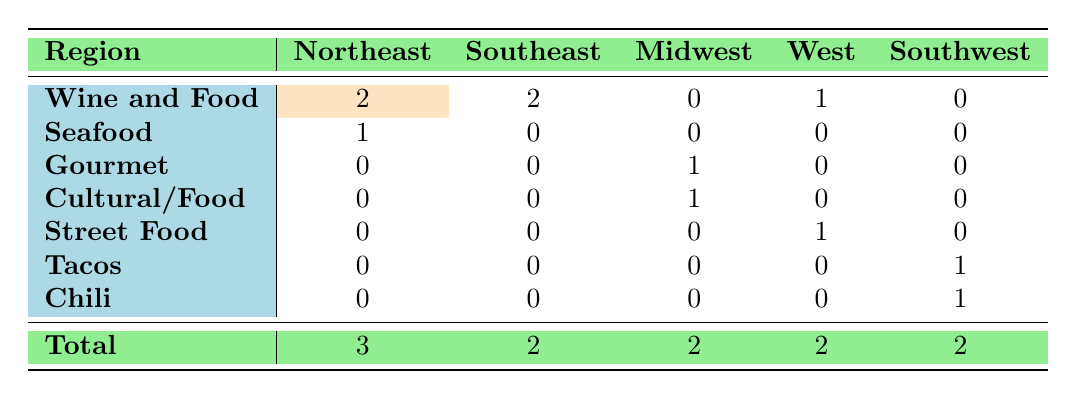What type of food festival has the highest attendance in the Northeast region? The table shows "New York City Wine & Food Festival" under the Northeast region with an attendance of 50,000, which is higher than any other festival in that region.
Answer: Wine and Food How many different types of food festivals are represented in the Midwest region? In the Midwest region, there are two different types listed: "Gourmet" and "Cultural/Food", making a total of 2 types.
Answer: 2 Are there any food festivals in the Southwest region that are not related to Wine and Food? The table shows "Arizona Taco Festival" and "New Mexico Chile Festival" in the Southwest region, both of which are not related to Wine and Food. Therefore, the answer is yes.
Answer: Yes What is the total number of Wine and Food festivals across all regions? By counting the rows under the "Wine and Food" type in the table, there are a total of 5: 2 in the Northeast, 2 in the Southeast, and 1 in the West.
Answer: 5 Which region has the highest diversity of food festival types based on the table? By analyzing the table, the Northeast has 3 types (Wine and Food, Seafood) while the Midwest has 2 types (Gourmet, Cultural/Food), Southeast has 2 types (Wine and Food), West has 2 types (Wine and Food, Street Food), and Southwest has 2 types (Tacos, Chili). Therefore, the Northeast has the highest diversity with 3 types.
Answer: Northeast 